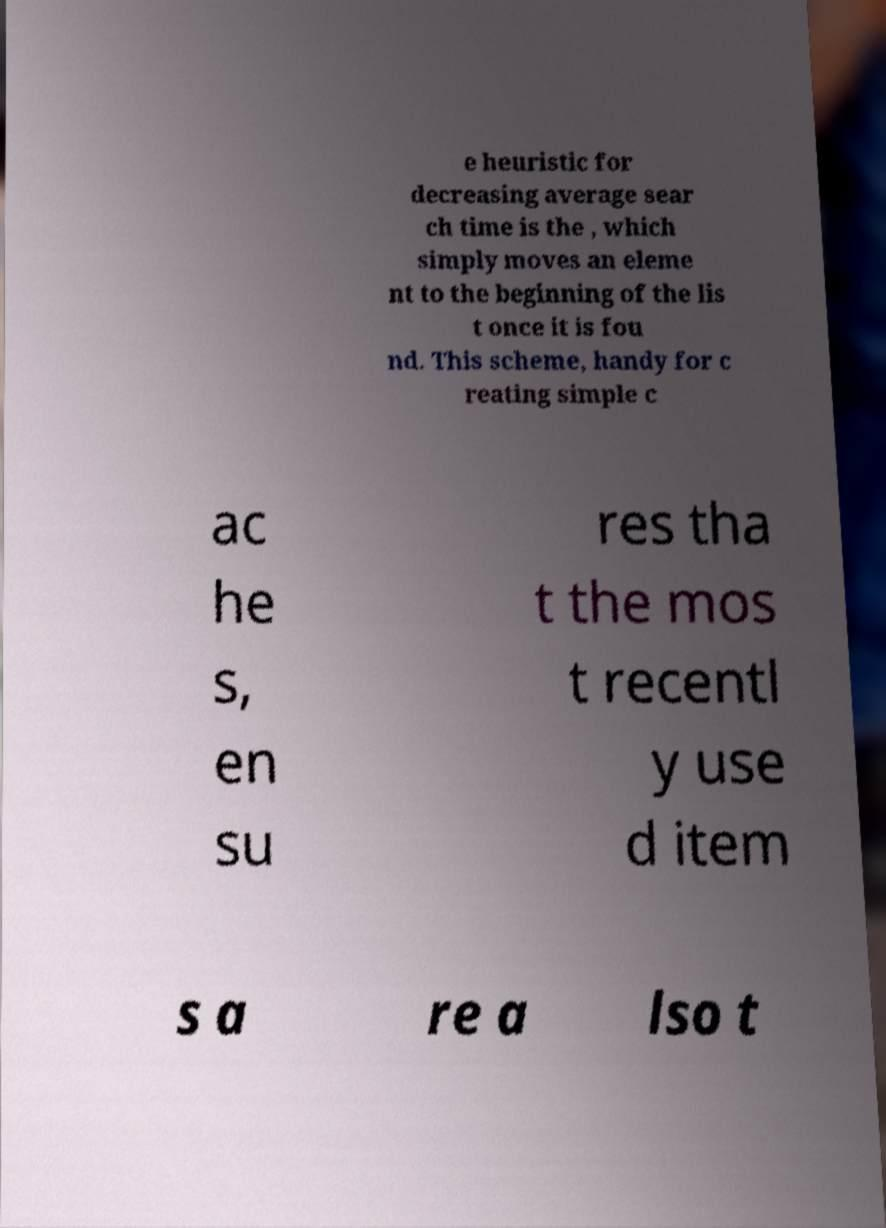Please identify and transcribe the text found in this image. e heuristic for decreasing average sear ch time is the , which simply moves an eleme nt to the beginning of the lis t once it is fou nd. This scheme, handy for c reating simple c ac he s, en su res tha t the mos t recentl y use d item s a re a lso t 